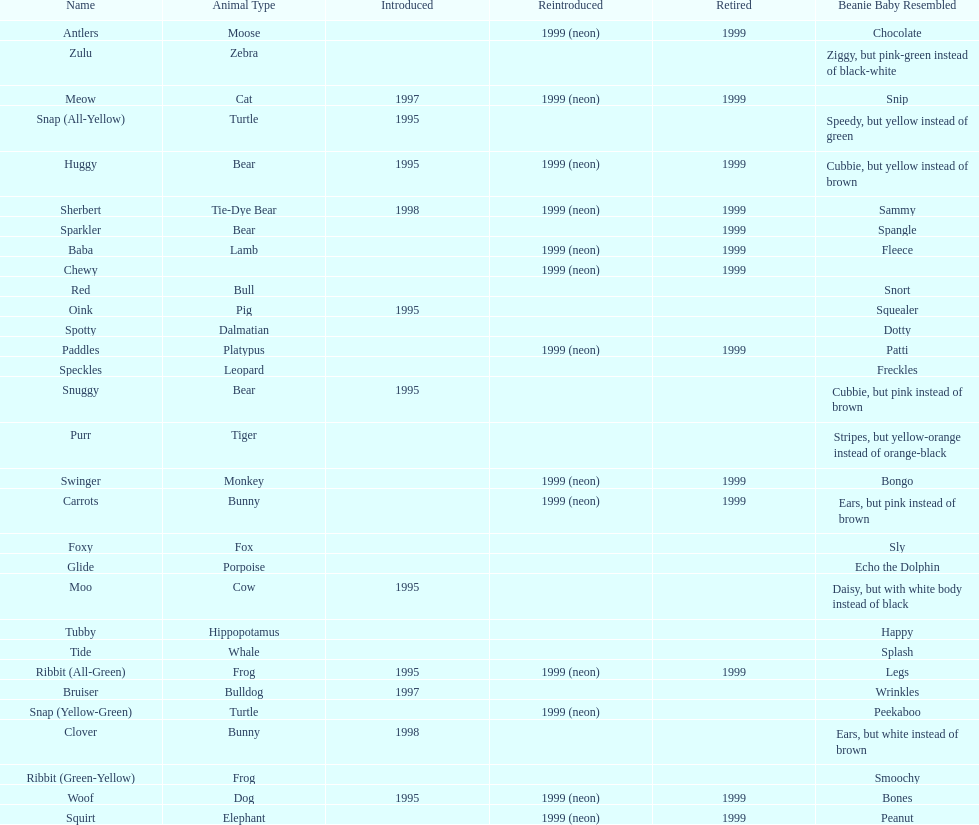In what year were the first pillow pals introduced? 1995. 